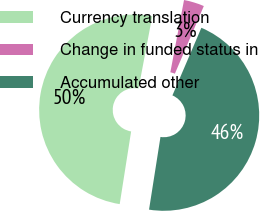Convert chart. <chart><loc_0><loc_0><loc_500><loc_500><pie_chart><fcel>Currency translation<fcel>Change in funded status in<fcel>Accumulated other<nl><fcel>50.49%<fcel>3.46%<fcel>46.04%<nl></chart> 